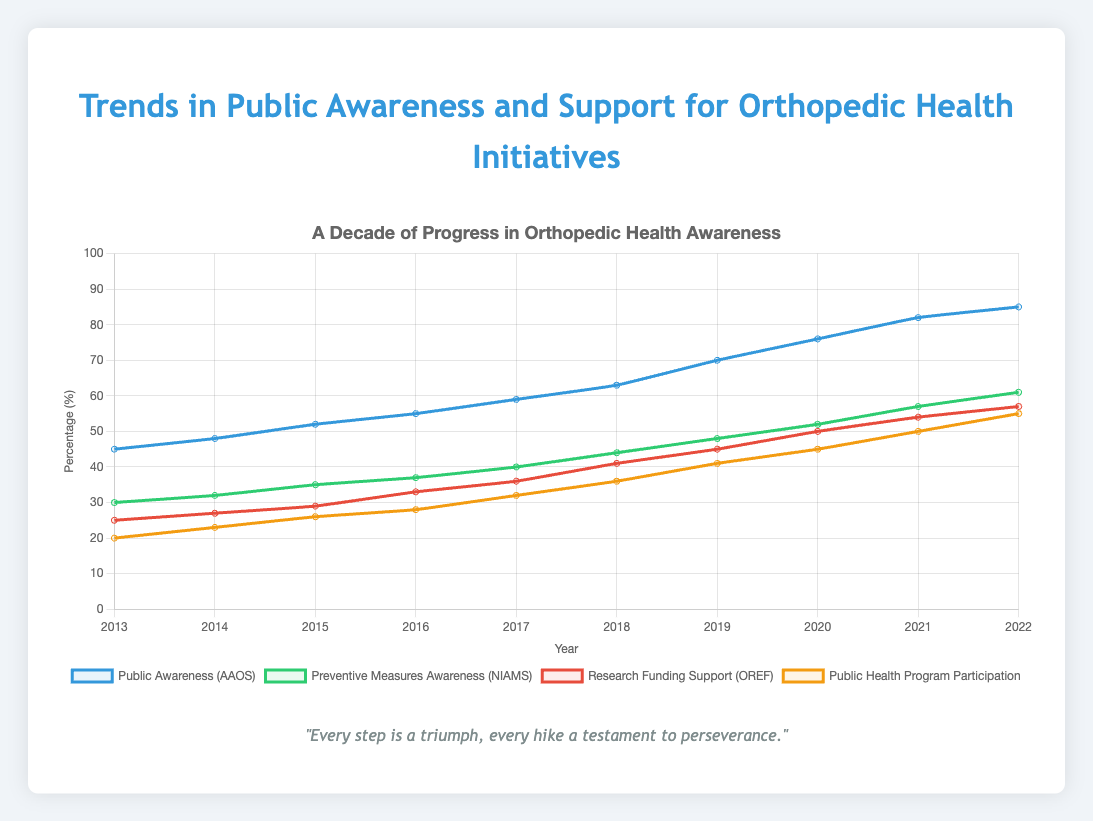what public health program had the lowest participation in 2015? Based on the chart, find the value for the 'Public Health Program Participation' dataset in 2015 and compare it to the other datasets at the same point in time.
Answer: Hike for Health How much did public awareness of orthopedic health increase from 2013 to 2020? Look at the value for ‘Public Awareness (AAOS)’ in 2013, which is 45, and in 2020, which is 76. Subtract the initial value from the final value: 76 - 45 = 31
Answer: 31 Compare the increase in preventive measure awareness from 2015 to 2019 with the increase in public health program participation over the same period. Find the values for 'Preventive Measures Awareness (NIAMS)' and 'Public Health Program Participation' in 2015 and 2019. For "Preventive Measures Awareness", the values are 35 and 48. For 'Public Health Program Participation', the values are 26 and 41. Calculate the increases: 48 - 35 = 13, and 41 - 26 = 15. Then, compare these differences.
Answer: Public health program participation increased by 2 more points than preventive measure awareness How did the support for research funding change between 2016 and 2022? Identify the values for 'Research Funding Support (OREF)' in 2016 (33) and 2022 (57). Subtract the initial value from the final: 57 - 33 = 24
Answer: 24 Which initiative had the largest absolute increase in public support from 2013 to 2022? Find the total increase for each dataset from 2013 to 2022 by subtracting the 2013 values from the 2022 values. The increases are: Public Awareness (40), Preventive Measures Awareness (31), Research Funding Support (32), Public Health Program Participation (35). Identify the maximum increase.
Answer: Public Awareness (AAOS) What year did public health program participation first reach 40 percent? Look at the 'Public Health Program Participation' trend and identify the year it reached or surpassed 40 for the first time, which is 2019.
Answer: 2019 Between which two consecutive years did research funding support experience the largest growth? Calculate the year-over-year changes for 'Research Funding Support (OREF)': 27-25=2, 29-27=2, 33-29=4, 36-33=3, 41-36=5, 45-41=4, 50-45=5, 54-50=4, 57-54=3. Identify the maximum difference: 41 to 45 and 45 to 50.
Answer: Between 2017 and 2018 / Between 2018 and 2019 What color represents the trend for 'Preventive Measures Awareness'? Refer to the visual attributes of the chart—‘Preventive Measures Awareness’ is shown in green.
Answer: Green On the chart, which year shows the same percentage for both 'Preventive Measures Awareness' and 'Research Funding Support'? Identify the year where the lines for 'Preventive Measures Awareness' and 'Research Funding Support' cross; this happens in 2016.
Answer: 2016 